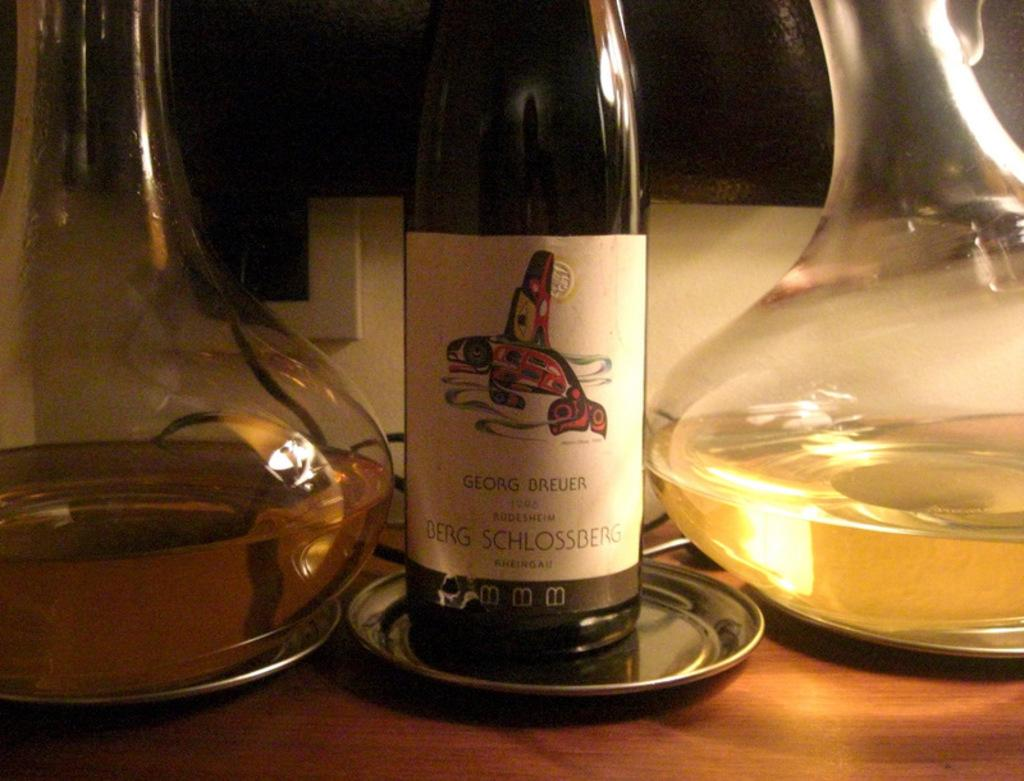<image>
Relay a brief, clear account of the picture shown. A bottle of Georg Brueuer wine sits on a table next to two decanters of wine 